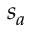<formula> <loc_0><loc_0><loc_500><loc_500>s _ { a }</formula> 